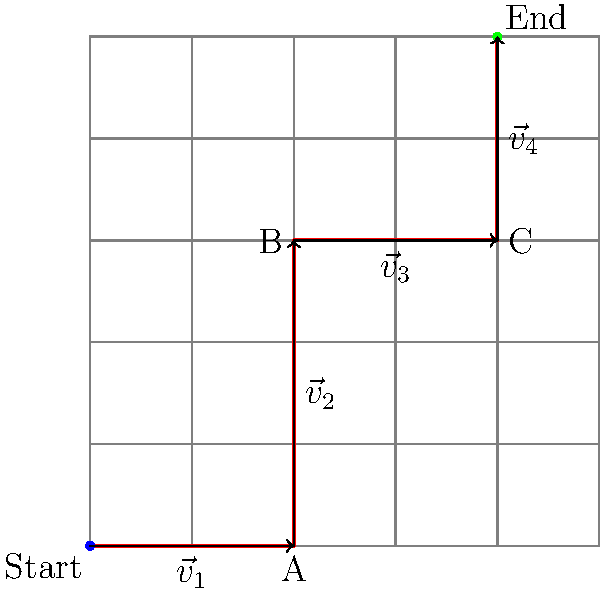As a food truck owner navigating through the city, you need to calculate the most efficient route from your starting point to your final destination. The map shows a grid representation of the city, where each unit represents one block. Your path is represented by the red line, broken down into four vector segments: $\vec{v}_1$, $\vec{v}_2$, $\vec{v}_3$, and $\vec{v}_4$. What is the total displacement vector $\vec{d}$ from your starting point to your final destination? To find the total displacement vector, we need to follow these steps:

1. Identify the individual vector components:
   $\vec{v}_1 = \langle 2, 0 \rangle$
   $\vec{v}_2 = \langle 0, 3 \rangle$
   $\vec{v}_3 = \langle 2, 0 \rangle$
   $\vec{v}_4 = \langle 0, 2 \rangle$

2. Add all the vectors together:
   $\vec{d} = \vec{v}_1 + \vec{v}_2 + \vec{v}_3 + \vec{v}_4$

3. Add the x-components:
   $d_x = 2 + 0 + 2 + 0 = 4$

4. Add the y-components:
   $d_y = 0 + 3 + 0 + 2 = 5$

5. Express the total displacement vector:
   $\vec{d} = \langle 4, 5 \rangle$

This vector represents the most direct path from the starting point to the final destination, regardless of the actual route taken.
Answer: $\vec{d} = \langle 4, 5 \rangle$ 